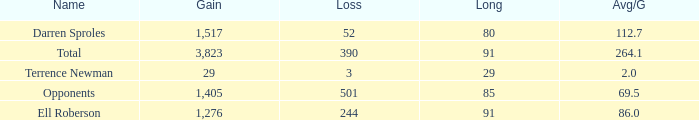What's the sum of all average yards gained when the gained yards is under 1,276 and lost more than 3 yards? None. 